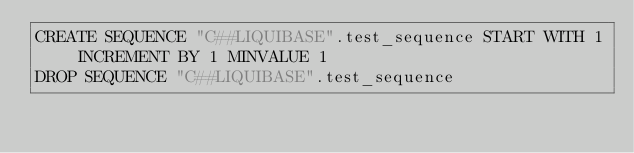Convert code to text. <code><loc_0><loc_0><loc_500><loc_500><_SQL_>CREATE SEQUENCE "C##LIQUIBASE".test_sequence START WITH 1 INCREMENT BY 1 MINVALUE 1
DROP SEQUENCE "C##LIQUIBASE".test_sequence</code> 